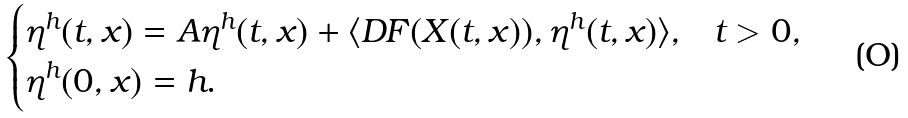Convert formula to latex. <formula><loc_0><loc_0><loc_500><loc_500>\begin{cases} \eta ^ { h } ( t , x ) = A \eta ^ { h } ( t , x ) + \langle D F ( X ( t , x ) ) , \eta ^ { h } ( t , x ) \rangle , & t > 0 , \\ \eta ^ { h } ( 0 , x ) = h . \end{cases}</formula> 